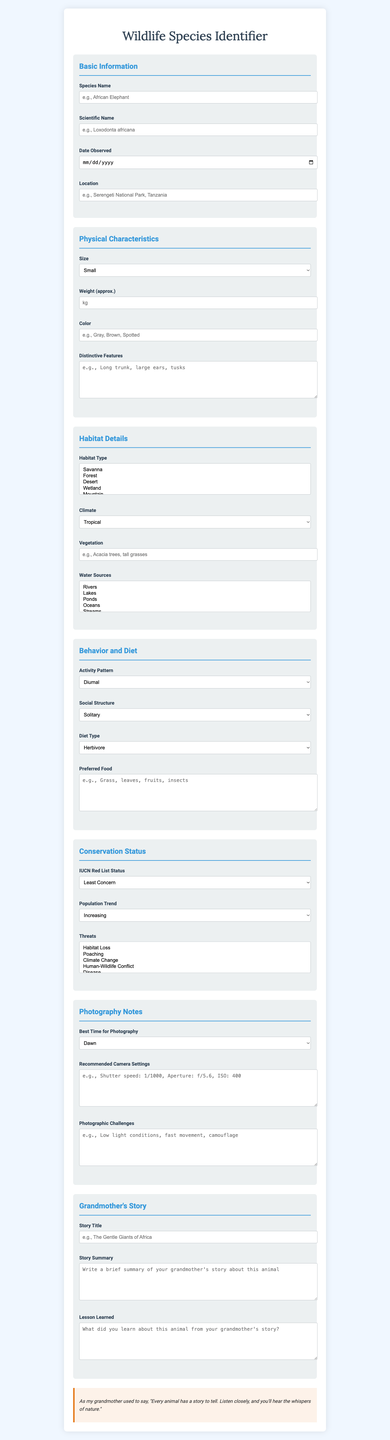what is the title of the form? The title of the form is mentioned at the top of the document.
Answer: Wildlife Species Identifier what is the scientific name field placeholder? The placeholder provides an example of what to enter in the scientific name field.
Answer: e.g., Loxodonta africana how many habitat types can be selected? The document indicates that multiple habitat types can be selected from the options given.
Answer: Multiple what is the size option for the animal? The size field allows for selection of different size categories for the animal species.
Answer: Small, Medium, Large, Extra Large which section contains the Climate field? This question requires locating the Climate field within the sections of the document.
Answer: Habitat Details what does the "IUCN Red List Status" dropdown include? The options in this dropdown provide specific conservation status categories for species.
Answer: Least Concern, Near Threatened, Vulnerable, Endangered, Critically Endangered what is the activity pattern option available? This question relates to understanding the behavior aspect referred to in the document.
Answer: Diurnal, Nocturnal, Crepuscular what should be included in the "Story Summary" field? This field invites the user to provide a summary based on their grandmother's narrative about the animal.
Answer: A brief summary of your grandmother's story about this animal what notable feature is mentioned for the "Distinctive Features" field? The placeholder suggests specific traits that may identify the species, indicating their morphology.
Answer: e.g., Long trunk, large ears, tusks 